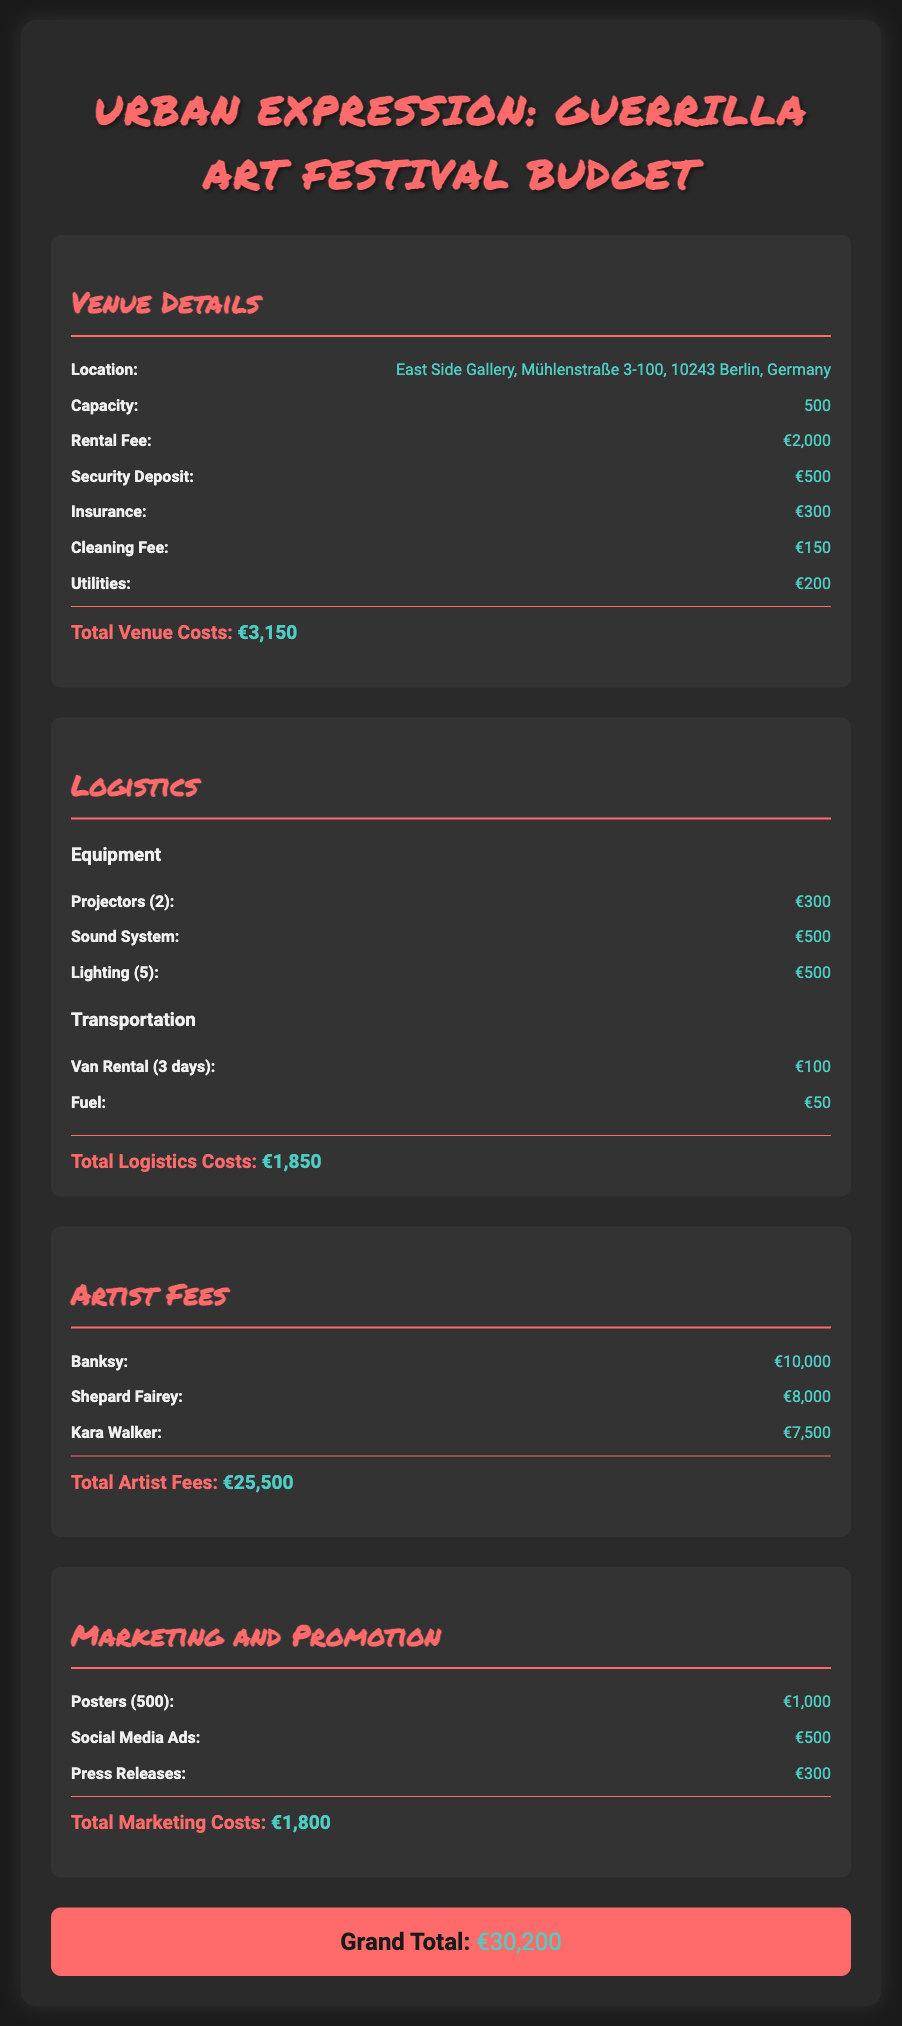What is the location of the event? The location is specified in the venue details, which state that the event will take place at East Side Gallery, Mühlenstraße 3-100, 10243 Berlin, Germany.
Answer: East Side Gallery, Mühlenstraße 3-100, 10243 Berlin, Germany What is the total cost for artist fees? The total cost for artist fees is the sum of the individual artist payments listed in the document, which amounts to €10,000 + €8,000 + €7,500 = €25,500.
Answer: €25,500 How many projectors are being rented? The equipment section specifies that 2 projectors are included in the logistics costs.
Answer: 2 What is the cleaning fee? The cleaning fee is detailed in the venue section and is stated as €150.
Answer: €150 What is the grand total of the budget? The grand total is the sum of all previous sections' totals, as indicated at the bottom of the document, which amounts to €30,200.
Answer: €30,200 How much is the rental fee for the venue? The rental fee for the venue is explicitly listed as €2,000 in the venue details.
Answer: €2,000 What are the costs for social media ads? The marketing section lists the cost for social media ads as €500.
Answer: €500 How many lighting units are included in the logistics? The logistics section states that there are 5 lighting units included in the equipment costs.
Answer: 5 What does the security deposit amount to? The security deposit is specified in the venue costs as €500.
Answer: €500 